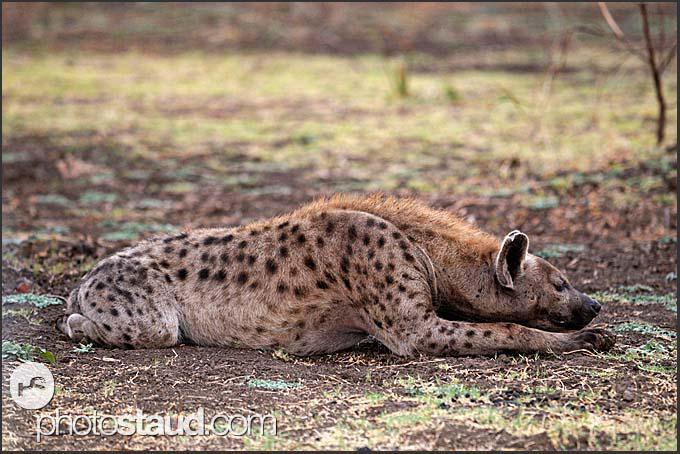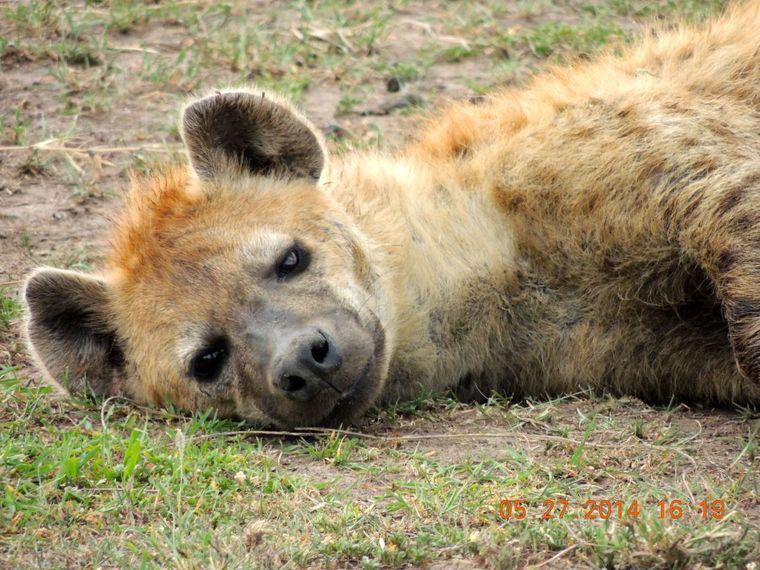The first image is the image on the left, the second image is the image on the right. Given the left and right images, does the statement "The animal in one of the images has its head laying directly on the ground." hold true? Answer yes or no. Yes. The first image is the image on the left, the second image is the image on the right. Considering the images on both sides, is "The left image features one adult hyena lying flat on its belly, and the right image includes an adult hyena reclining in some position." valid? Answer yes or no. Yes. 